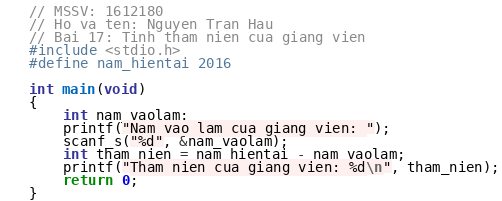Convert code to text. <code><loc_0><loc_0><loc_500><loc_500><_C++_>// MSSV: 1612180
// Ho va ten: Nguyen Tran Hau
// Bai 17: Tinh tham nien cua giang vien
#include <stdio.h>
#define nam_hientai 2016

int main(void)
{
	int nam_vaolam;
	printf("Nam vao lam cua giang vien: ");
	scanf_s("%d", &nam_vaolam);
	int tham_nien = nam_hientai - nam_vaolam;
	printf("Tham nien cua giang vien: %d\n", tham_nien);
	return 0;
}</code> 